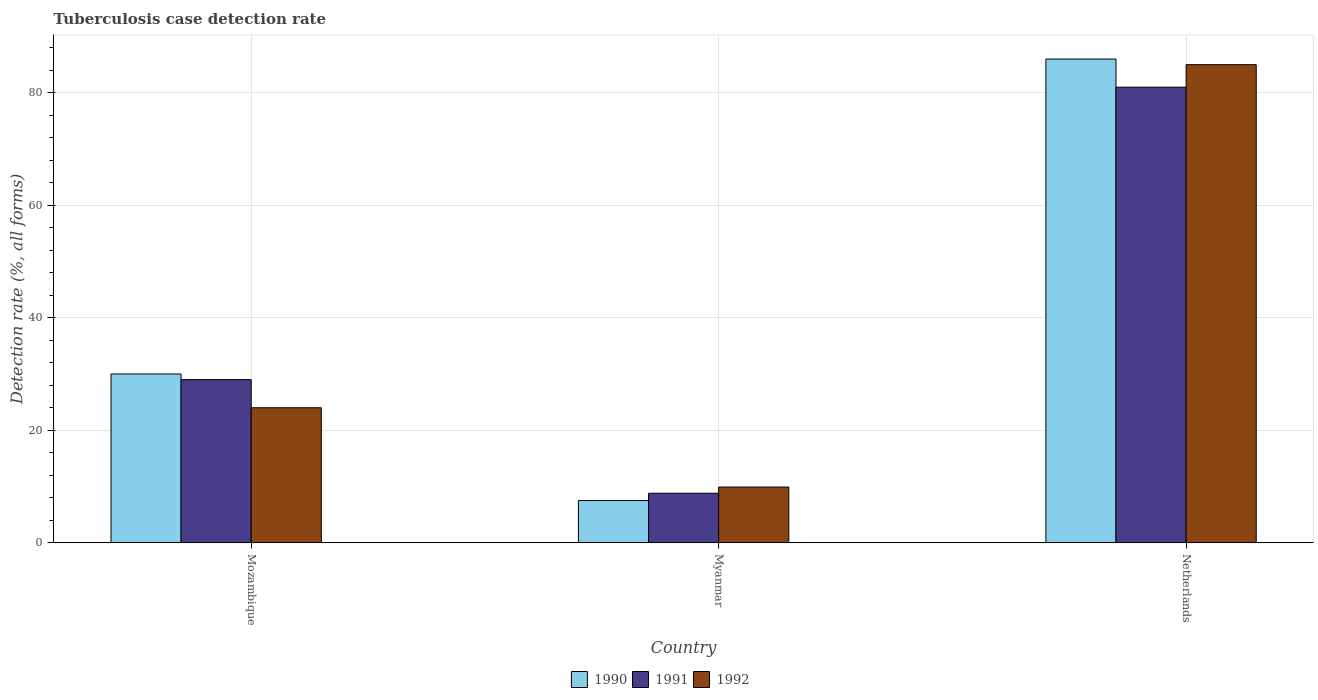How many groups of bars are there?
Provide a short and direct response. 3. How many bars are there on the 1st tick from the left?
Your answer should be compact. 3. How many bars are there on the 2nd tick from the right?
Keep it short and to the point. 3. What is the label of the 2nd group of bars from the left?
Make the answer very short. Myanmar. What is the tuberculosis case detection rate in in 1990 in Netherlands?
Your answer should be compact. 86. Across all countries, what is the maximum tuberculosis case detection rate in in 1992?
Your answer should be compact. 85. Across all countries, what is the minimum tuberculosis case detection rate in in 1990?
Your answer should be compact. 7.5. In which country was the tuberculosis case detection rate in in 1991 maximum?
Your answer should be compact. Netherlands. In which country was the tuberculosis case detection rate in in 1990 minimum?
Provide a short and direct response. Myanmar. What is the total tuberculosis case detection rate in in 1992 in the graph?
Provide a succinct answer. 118.9. What is the difference between the tuberculosis case detection rate in in 1990 in Mozambique and that in Netherlands?
Ensure brevity in your answer.  -56. What is the difference between the tuberculosis case detection rate in in 1992 in Netherlands and the tuberculosis case detection rate in in 1990 in Myanmar?
Your answer should be very brief. 77.5. What is the average tuberculosis case detection rate in in 1990 per country?
Make the answer very short. 41.17. What is the difference between the tuberculosis case detection rate in of/in 1992 and tuberculosis case detection rate in of/in 1990 in Myanmar?
Give a very brief answer. 2.4. In how many countries, is the tuberculosis case detection rate in in 1991 greater than 16 %?
Give a very brief answer. 2. What is the ratio of the tuberculosis case detection rate in in 1991 in Myanmar to that in Netherlands?
Provide a succinct answer. 0.11. Is the difference between the tuberculosis case detection rate in in 1992 in Mozambique and Netherlands greater than the difference between the tuberculosis case detection rate in in 1990 in Mozambique and Netherlands?
Keep it short and to the point. No. What is the difference between the highest and the second highest tuberculosis case detection rate in in 1990?
Provide a succinct answer. -78.5. What is the difference between the highest and the lowest tuberculosis case detection rate in in 1990?
Your response must be concise. 78.5. Is the sum of the tuberculosis case detection rate in in 1990 in Mozambique and Myanmar greater than the maximum tuberculosis case detection rate in in 1991 across all countries?
Make the answer very short. No. Is it the case that in every country, the sum of the tuberculosis case detection rate in in 1990 and tuberculosis case detection rate in in 1992 is greater than the tuberculosis case detection rate in in 1991?
Provide a succinct answer. Yes. How many bars are there?
Your response must be concise. 9. Are all the bars in the graph horizontal?
Your response must be concise. No. How many countries are there in the graph?
Offer a very short reply. 3. Does the graph contain any zero values?
Provide a succinct answer. No. Where does the legend appear in the graph?
Ensure brevity in your answer.  Bottom center. What is the title of the graph?
Provide a short and direct response. Tuberculosis case detection rate. Does "1971" appear as one of the legend labels in the graph?
Your answer should be very brief. No. What is the label or title of the Y-axis?
Offer a terse response. Detection rate (%, all forms). What is the Detection rate (%, all forms) in 1991 in Mozambique?
Your response must be concise. 29. What is the Detection rate (%, all forms) of 1990 in Myanmar?
Ensure brevity in your answer.  7.5. What is the Detection rate (%, all forms) of 1990 in Netherlands?
Provide a short and direct response. 86. Across all countries, what is the maximum Detection rate (%, all forms) in 1991?
Your answer should be very brief. 81. Across all countries, what is the minimum Detection rate (%, all forms) of 1990?
Keep it short and to the point. 7.5. Across all countries, what is the minimum Detection rate (%, all forms) of 1991?
Your response must be concise. 8.8. Across all countries, what is the minimum Detection rate (%, all forms) in 1992?
Your answer should be compact. 9.9. What is the total Detection rate (%, all forms) in 1990 in the graph?
Give a very brief answer. 123.5. What is the total Detection rate (%, all forms) in 1991 in the graph?
Offer a terse response. 118.8. What is the total Detection rate (%, all forms) in 1992 in the graph?
Make the answer very short. 118.9. What is the difference between the Detection rate (%, all forms) in 1990 in Mozambique and that in Myanmar?
Your response must be concise. 22.5. What is the difference between the Detection rate (%, all forms) of 1991 in Mozambique and that in Myanmar?
Keep it short and to the point. 20.2. What is the difference between the Detection rate (%, all forms) in 1992 in Mozambique and that in Myanmar?
Your answer should be very brief. 14.1. What is the difference between the Detection rate (%, all forms) in 1990 in Mozambique and that in Netherlands?
Your response must be concise. -56. What is the difference between the Detection rate (%, all forms) of 1991 in Mozambique and that in Netherlands?
Make the answer very short. -52. What is the difference between the Detection rate (%, all forms) of 1992 in Mozambique and that in Netherlands?
Offer a very short reply. -61. What is the difference between the Detection rate (%, all forms) of 1990 in Myanmar and that in Netherlands?
Offer a very short reply. -78.5. What is the difference between the Detection rate (%, all forms) in 1991 in Myanmar and that in Netherlands?
Offer a very short reply. -72.2. What is the difference between the Detection rate (%, all forms) of 1992 in Myanmar and that in Netherlands?
Your response must be concise. -75.1. What is the difference between the Detection rate (%, all forms) of 1990 in Mozambique and the Detection rate (%, all forms) of 1991 in Myanmar?
Ensure brevity in your answer.  21.2. What is the difference between the Detection rate (%, all forms) in 1990 in Mozambique and the Detection rate (%, all forms) in 1992 in Myanmar?
Ensure brevity in your answer.  20.1. What is the difference between the Detection rate (%, all forms) of 1991 in Mozambique and the Detection rate (%, all forms) of 1992 in Myanmar?
Provide a short and direct response. 19.1. What is the difference between the Detection rate (%, all forms) in 1990 in Mozambique and the Detection rate (%, all forms) in 1991 in Netherlands?
Keep it short and to the point. -51. What is the difference between the Detection rate (%, all forms) of 1990 in Mozambique and the Detection rate (%, all forms) of 1992 in Netherlands?
Offer a very short reply. -55. What is the difference between the Detection rate (%, all forms) of 1991 in Mozambique and the Detection rate (%, all forms) of 1992 in Netherlands?
Offer a very short reply. -56. What is the difference between the Detection rate (%, all forms) of 1990 in Myanmar and the Detection rate (%, all forms) of 1991 in Netherlands?
Ensure brevity in your answer.  -73.5. What is the difference between the Detection rate (%, all forms) in 1990 in Myanmar and the Detection rate (%, all forms) in 1992 in Netherlands?
Offer a very short reply. -77.5. What is the difference between the Detection rate (%, all forms) of 1991 in Myanmar and the Detection rate (%, all forms) of 1992 in Netherlands?
Your response must be concise. -76.2. What is the average Detection rate (%, all forms) in 1990 per country?
Keep it short and to the point. 41.17. What is the average Detection rate (%, all forms) of 1991 per country?
Offer a very short reply. 39.6. What is the average Detection rate (%, all forms) in 1992 per country?
Your response must be concise. 39.63. What is the difference between the Detection rate (%, all forms) of 1990 and Detection rate (%, all forms) of 1992 in Mozambique?
Give a very brief answer. 6. What is the difference between the Detection rate (%, all forms) of 1991 and Detection rate (%, all forms) of 1992 in Mozambique?
Make the answer very short. 5. What is the difference between the Detection rate (%, all forms) in 1990 and Detection rate (%, all forms) in 1992 in Myanmar?
Keep it short and to the point. -2.4. What is the difference between the Detection rate (%, all forms) of 1991 and Detection rate (%, all forms) of 1992 in Myanmar?
Provide a short and direct response. -1.1. What is the difference between the Detection rate (%, all forms) of 1990 and Detection rate (%, all forms) of 1991 in Netherlands?
Keep it short and to the point. 5. What is the difference between the Detection rate (%, all forms) in 1990 and Detection rate (%, all forms) in 1992 in Netherlands?
Your answer should be very brief. 1. What is the ratio of the Detection rate (%, all forms) in 1990 in Mozambique to that in Myanmar?
Your answer should be very brief. 4. What is the ratio of the Detection rate (%, all forms) of 1991 in Mozambique to that in Myanmar?
Make the answer very short. 3.3. What is the ratio of the Detection rate (%, all forms) of 1992 in Mozambique to that in Myanmar?
Your answer should be very brief. 2.42. What is the ratio of the Detection rate (%, all forms) in 1990 in Mozambique to that in Netherlands?
Provide a succinct answer. 0.35. What is the ratio of the Detection rate (%, all forms) in 1991 in Mozambique to that in Netherlands?
Your answer should be compact. 0.36. What is the ratio of the Detection rate (%, all forms) in 1992 in Mozambique to that in Netherlands?
Offer a terse response. 0.28. What is the ratio of the Detection rate (%, all forms) in 1990 in Myanmar to that in Netherlands?
Offer a very short reply. 0.09. What is the ratio of the Detection rate (%, all forms) in 1991 in Myanmar to that in Netherlands?
Keep it short and to the point. 0.11. What is the ratio of the Detection rate (%, all forms) of 1992 in Myanmar to that in Netherlands?
Ensure brevity in your answer.  0.12. What is the difference between the highest and the second highest Detection rate (%, all forms) of 1991?
Keep it short and to the point. 52. What is the difference between the highest and the lowest Detection rate (%, all forms) of 1990?
Provide a short and direct response. 78.5. What is the difference between the highest and the lowest Detection rate (%, all forms) of 1991?
Keep it short and to the point. 72.2. What is the difference between the highest and the lowest Detection rate (%, all forms) in 1992?
Your answer should be very brief. 75.1. 